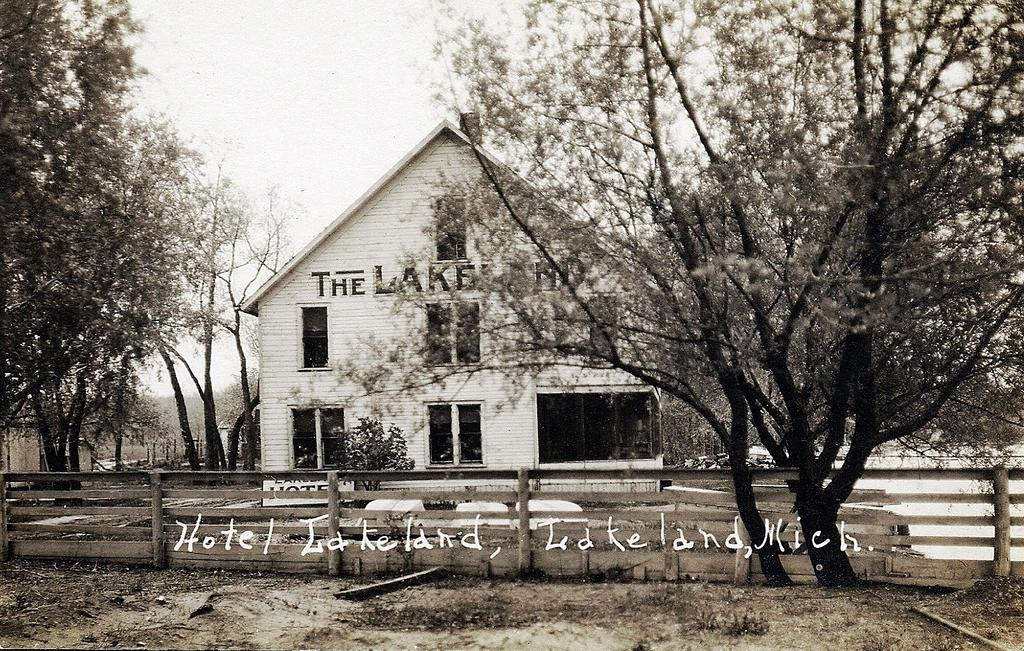<image>
Give a short and clear explanation of the subsequent image. A photograph of a building inscribed Hotel Lakeland. 